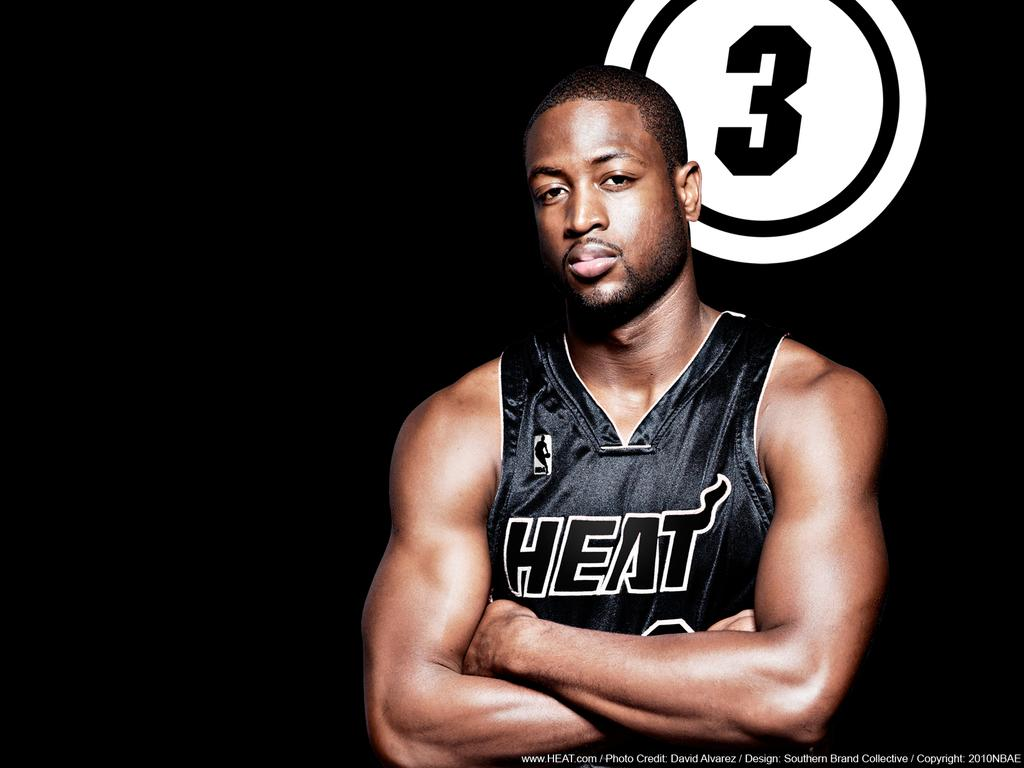Provide a one-sentence caption for the provided image. A guy in a Heat jersey is standing in front of the number 3. 